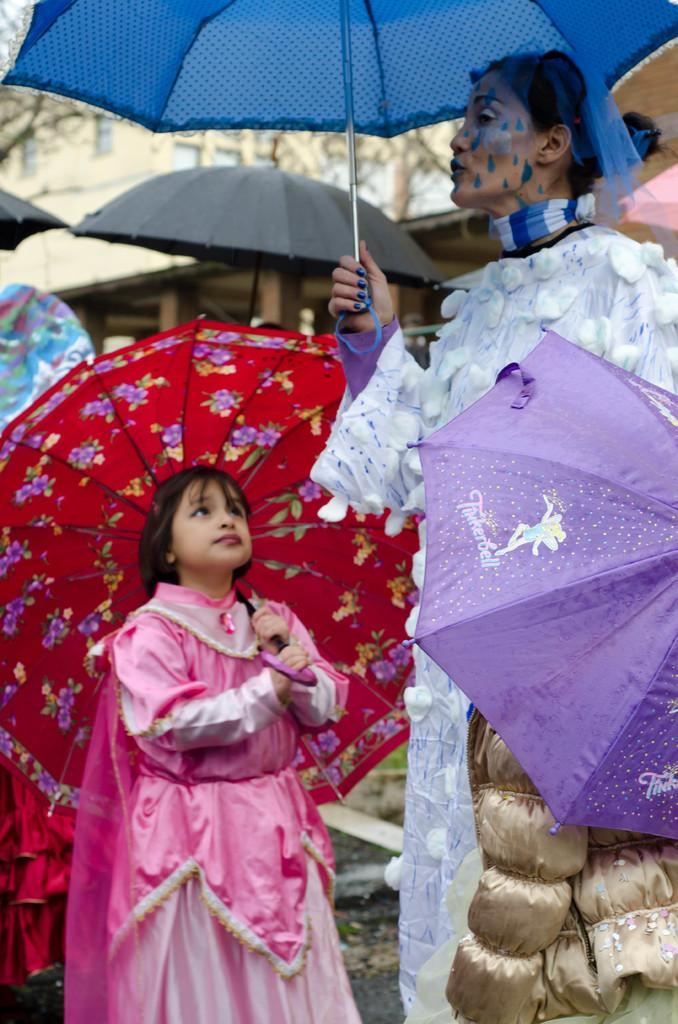What are the people in the image doing? The persons standing in the image are holding an umbrella. What can be seen in the background of the image? There is a building and trees in the background of the image. What type of kite is being flown by the persons in the image? There is no kite present in the image; the persons are holding an umbrella. How does the image show the persons stopping trouble? The image does not depict any trouble or the persons stopping it; it simply shows them holding an umbrella. 